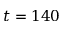<formula> <loc_0><loc_0><loc_500><loc_500>t = 1 4 0</formula> 